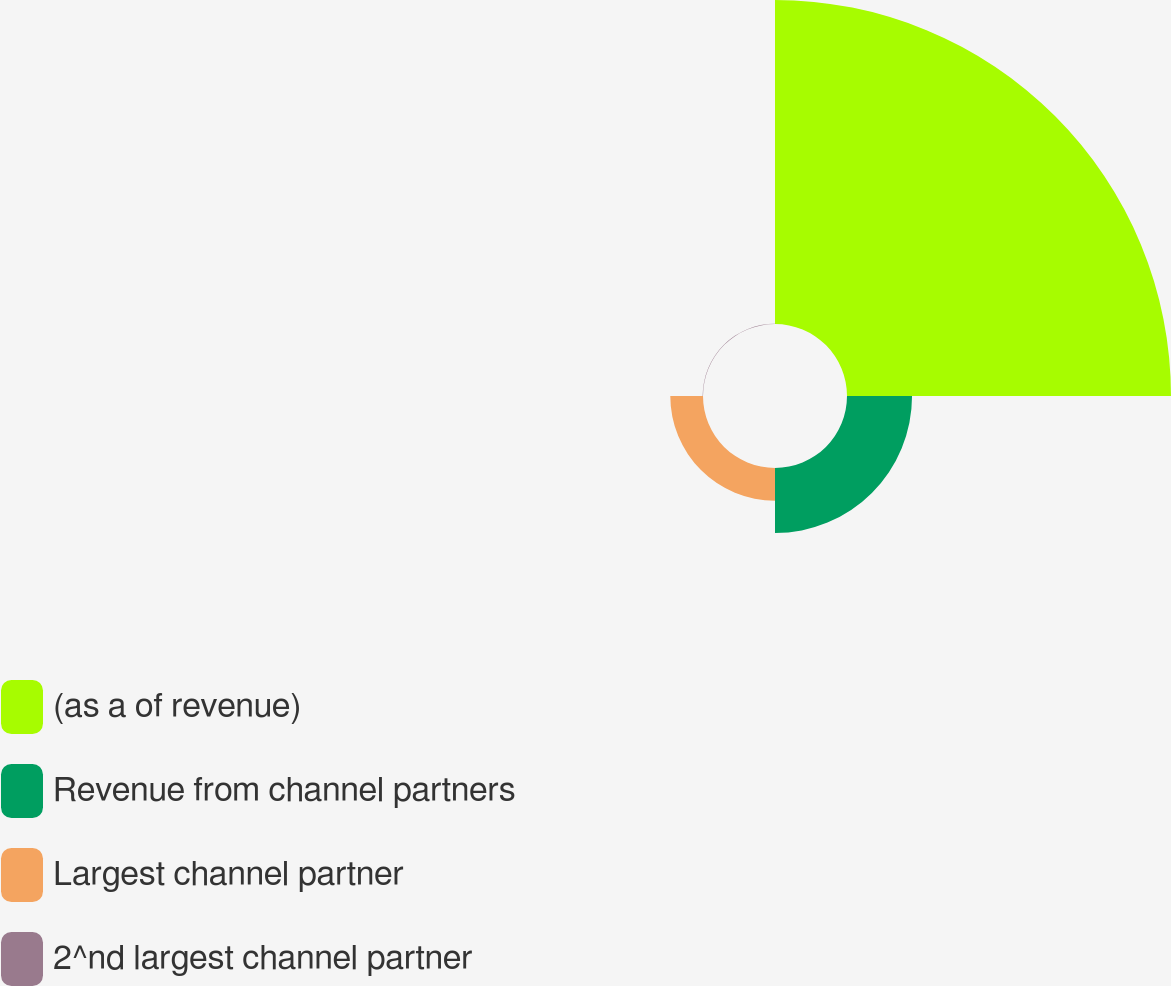Convert chart to OTSL. <chart><loc_0><loc_0><loc_500><loc_500><pie_chart><fcel>(as a of revenue)<fcel>Revenue from channel partners<fcel>Largest channel partner<fcel>2^nd largest channel partner<nl><fcel>76.76%<fcel>15.41%<fcel>7.75%<fcel>0.08%<nl></chart> 